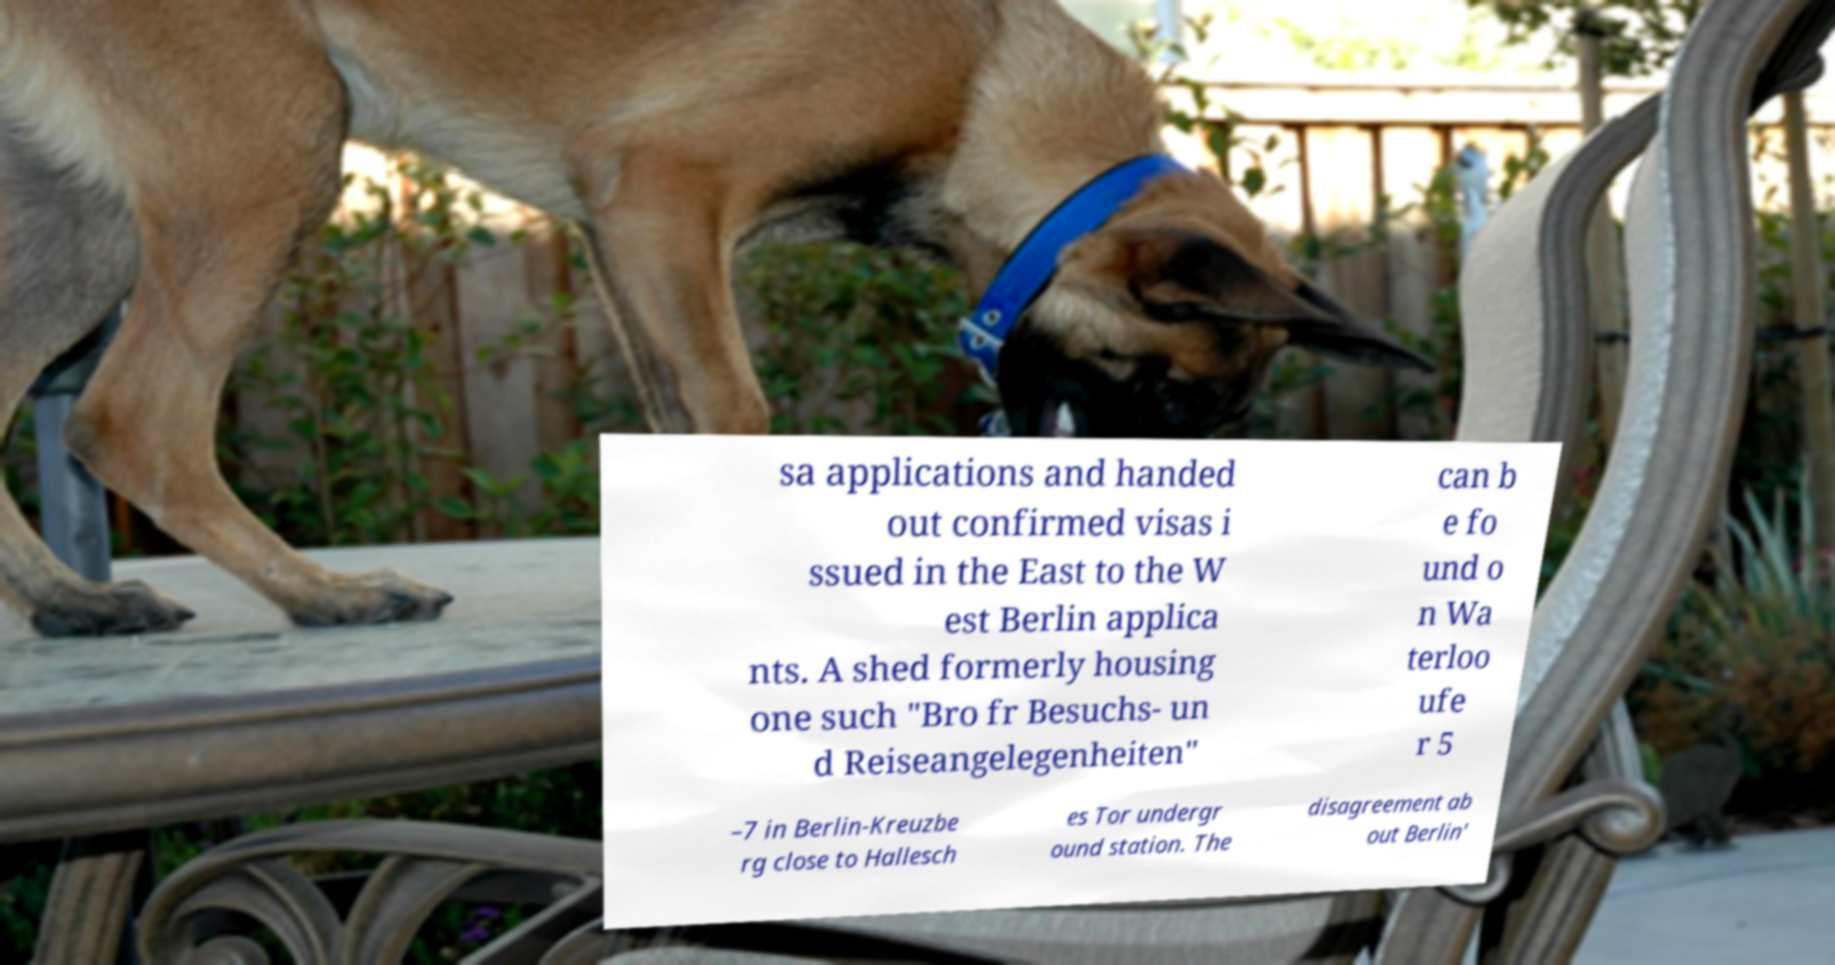Can you read and provide the text displayed in the image?This photo seems to have some interesting text. Can you extract and type it out for me? sa applications and handed out confirmed visas i ssued in the East to the W est Berlin applica nts. A shed formerly housing one such "Bro fr Besuchs- un d Reiseangelegenheiten" can b e fo und o n Wa terloo ufe r 5 –7 in Berlin-Kreuzbe rg close to Hallesch es Tor undergr ound station. The disagreement ab out Berlin' 